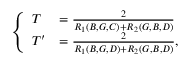<formula> <loc_0><loc_0><loc_500><loc_500>\left \{ \begin{array} { l l } { T } & { = \frac { 2 } { R _ { 1 } ( B , G , C ) + R _ { 2 } ( G , B , D ) } } \\ { T ^ { \prime } } & { = \frac { 2 } { R _ { 1 } ( B , G , D ) + R _ { 2 } ( G , B , D ) } , } \end{array}</formula> 